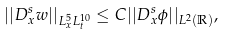Convert formula to latex. <formula><loc_0><loc_0><loc_500><loc_500>| | D _ { x } ^ { s } w | | _ { L _ { x } ^ { 5 } L _ { t } ^ { 1 0 } } \leq C | | D _ { x } ^ { s } \phi | | _ { L ^ { 2 } ( { \mathbb { R } } ) } ,</formula> 